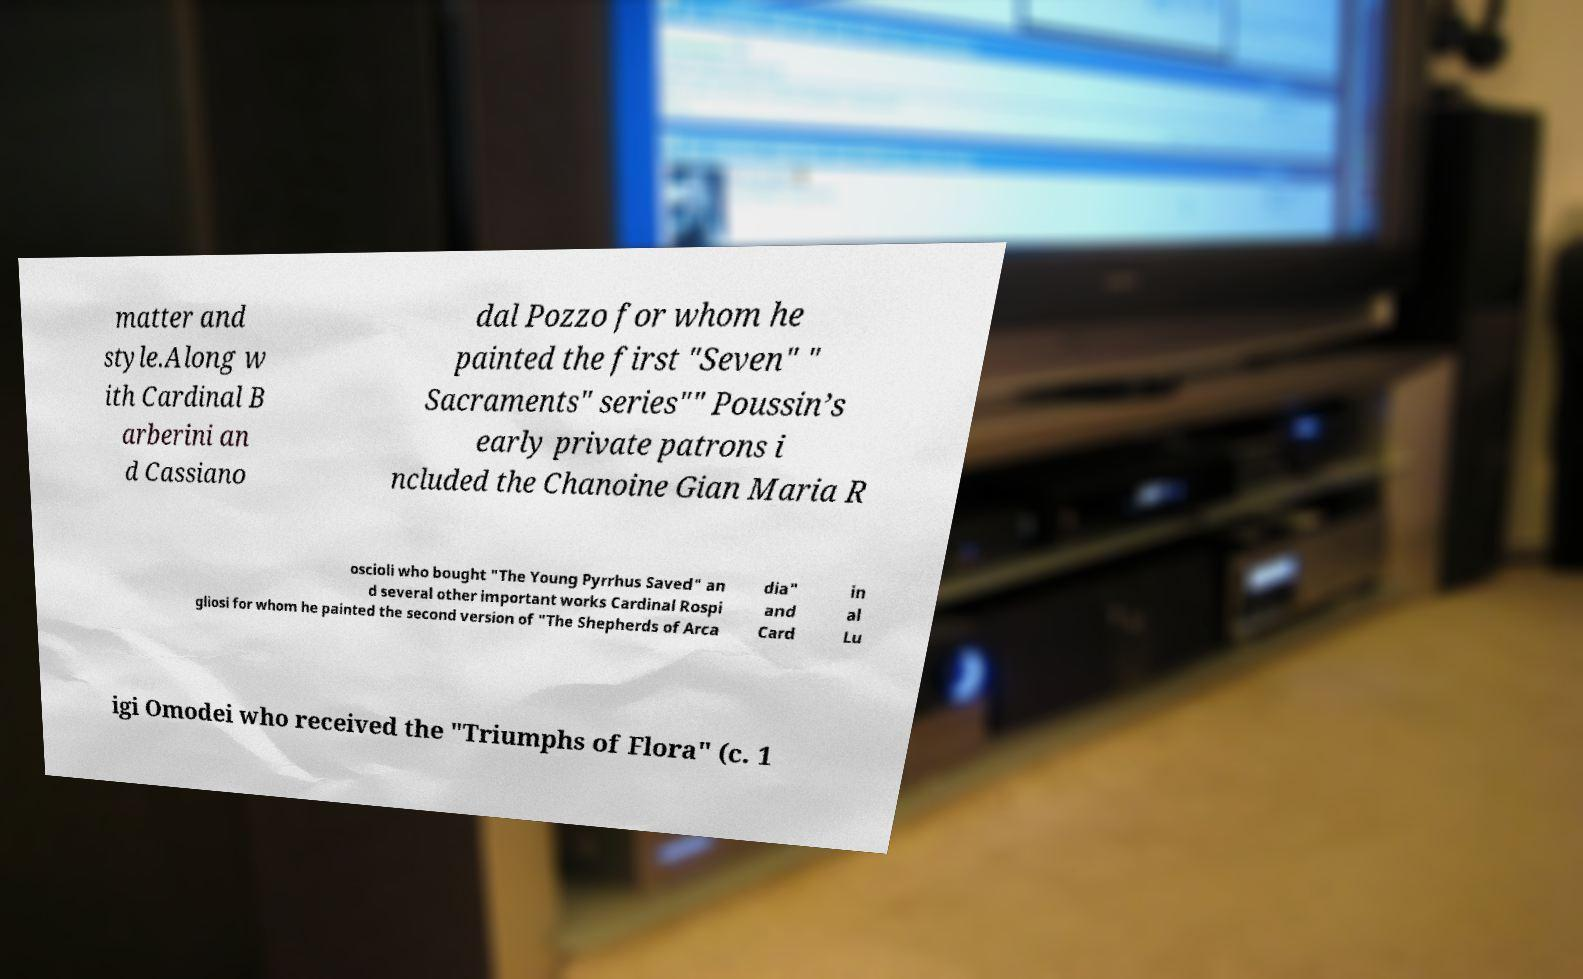What messages or text are displayed in this image? I need them in a readable, typed format. matter and style.Along w ith Cardinal B arberini an d Cassiano dal Pozzo for whom he painted the first "Seven" " Sacraments" series"" Poussin’s early private patrons i ncluded the Chanoine Gian Maria R oscioli who bought "The Young Pyrrhus Saved" an d several other important works Cardinal Rospi gliosi for whom he painted the second version of "The Shepherds of Arca dia" and Card in al Lu igi Omodei who received the "Triumphs of Flora" (c. 1 